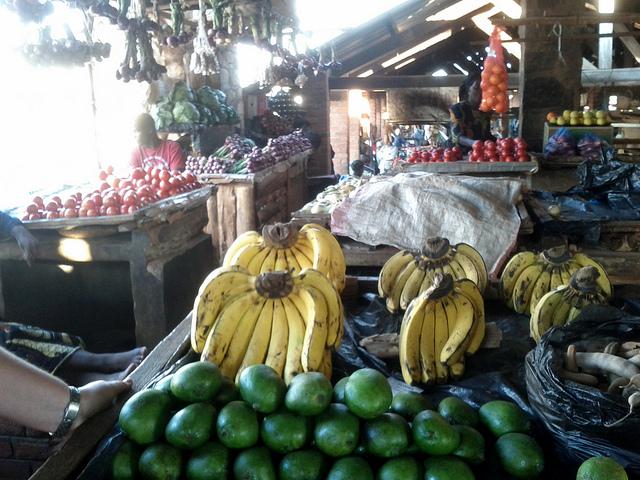What color is the fruit in the front?
Write a very short answer. Green. How many banana bunches are there?
Quick response, please. 6. What is the yellow fruit?
Answer briefly. Bananas. 